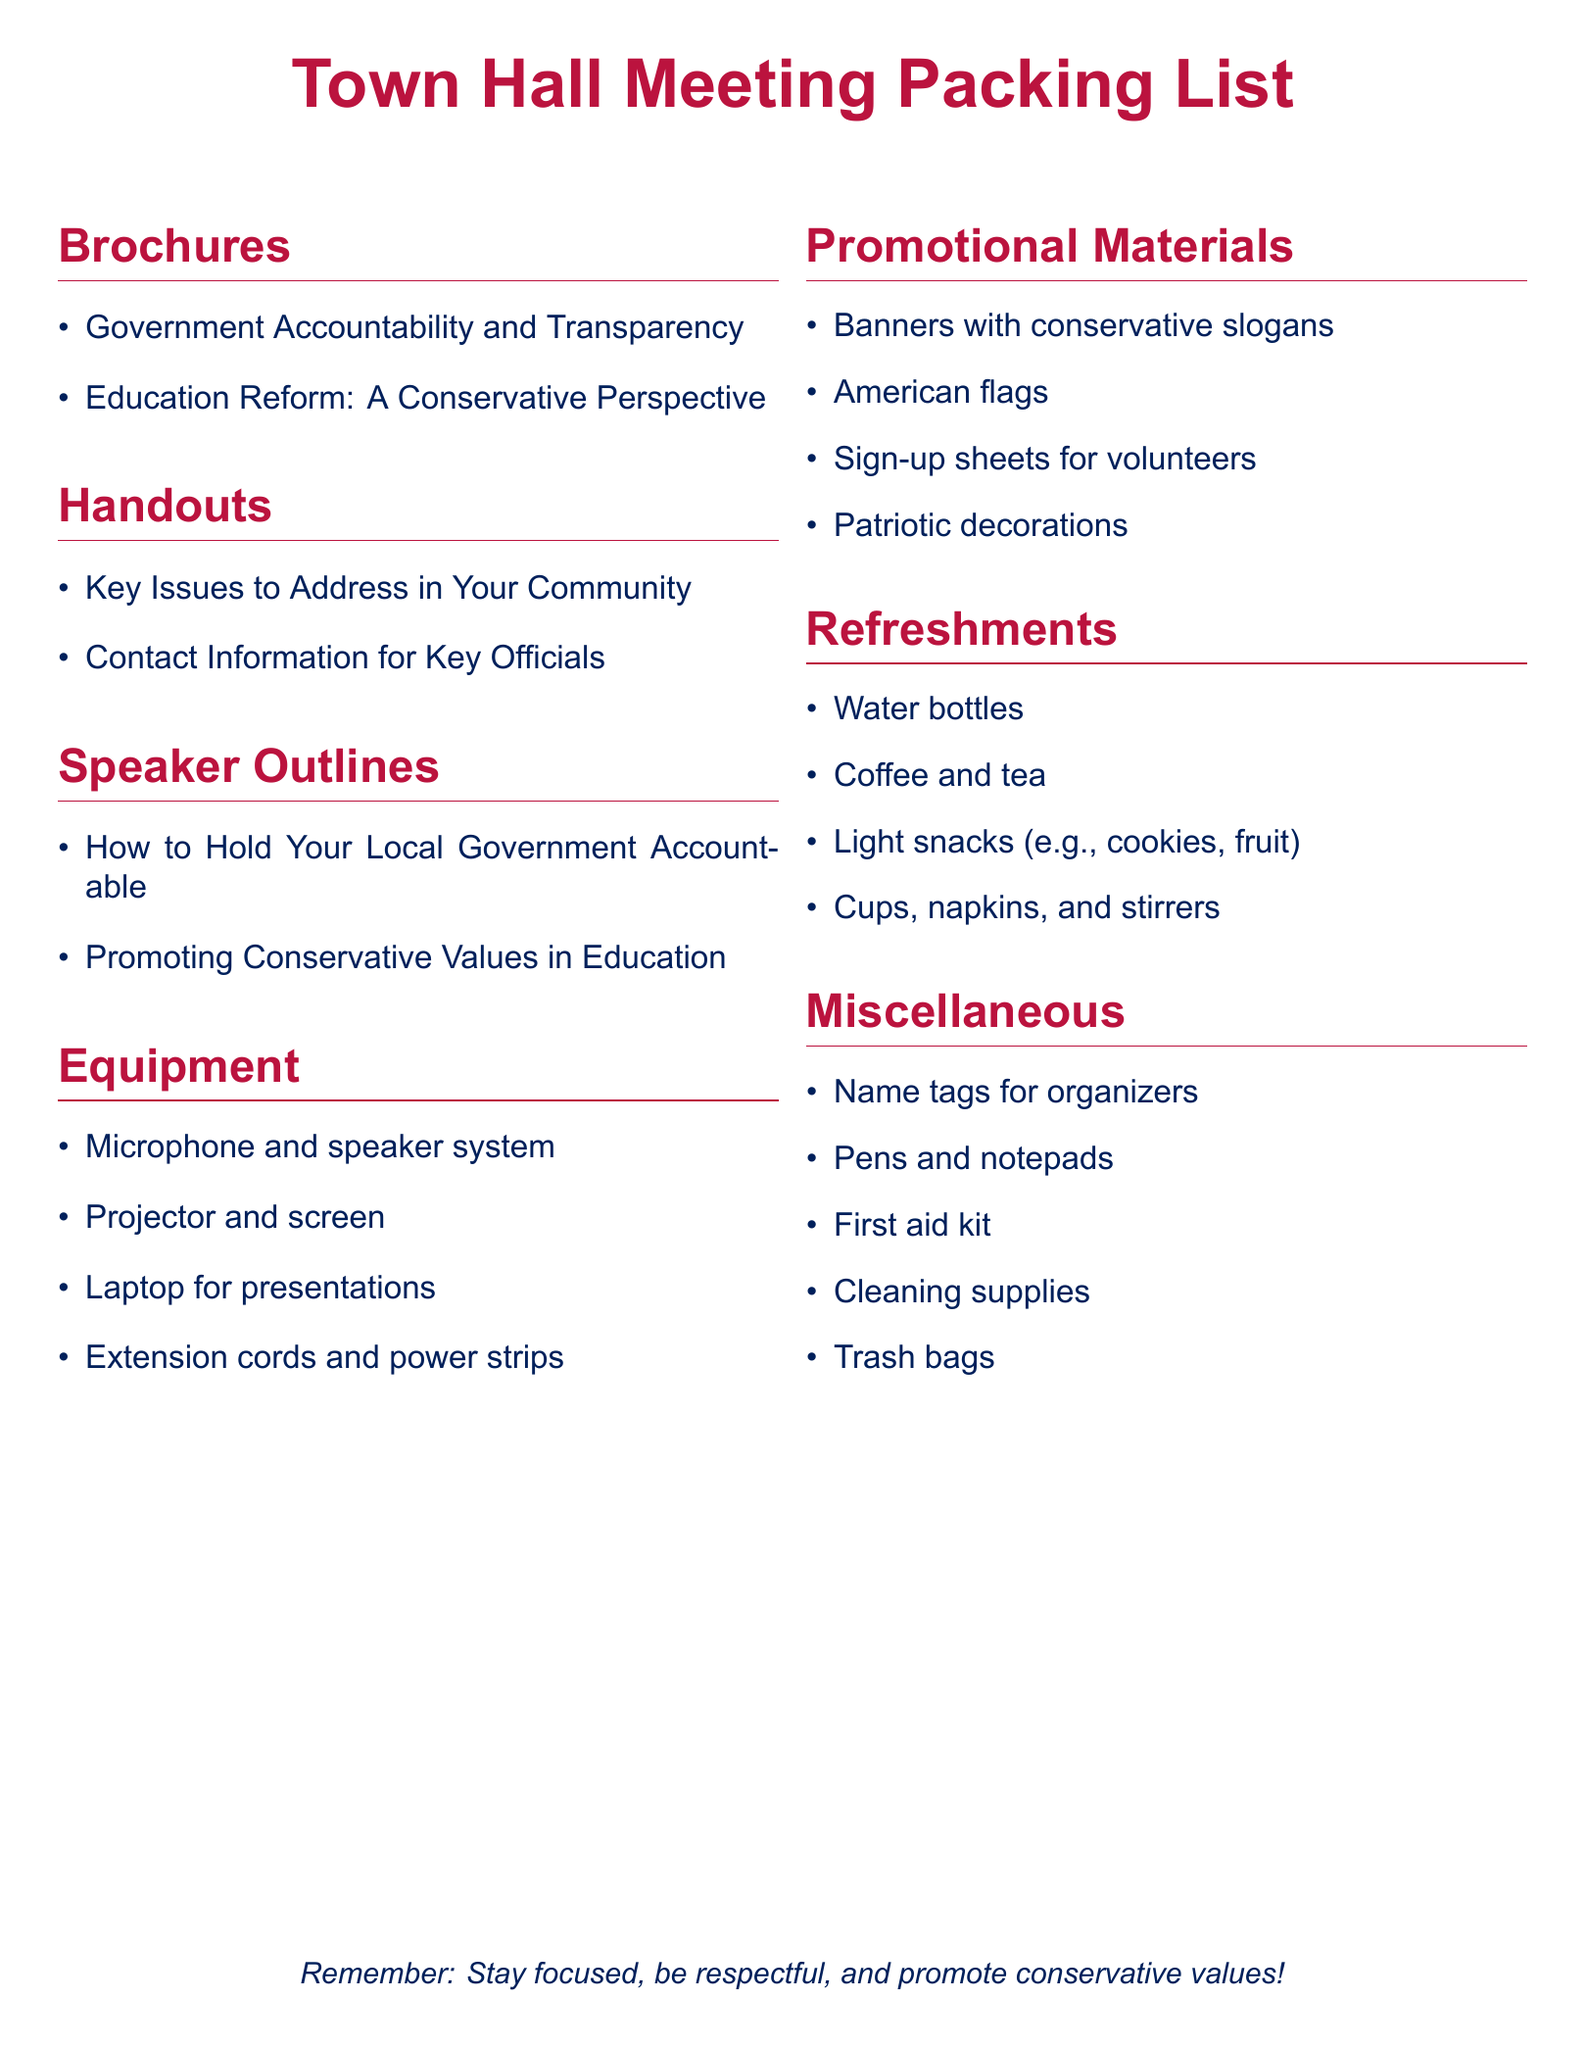What are two types of brochures listed? The document lists brochures related to Government Accountability and Transparency and Education Reform from a Conservative Perspective.
Answer: Government Accountability and Transparency; Education Reform: A Conservative Perspective What items are included under "Handouts"? The handouts section consists of Key Issues to Address in Your Community and Contact Information for Key Officials.
Answer: Key Issues to Address in Your Community; Contact Information for Key Officials How many sections are there in the packing list? The document contains six sections: Brochures, Handouts, Speaker Outlines, Equipment, Promotional Materials, Refreshments, and Miscellaneous, totaling seven sections.
Answer: Seven What is one essential piece of equipment mentioned? The packing list includes items like a microphone and speaker system, which is essential for the meeting.
Answer: Microphone and speaker system What type of refreshments are provided? The refreshments section specifies providing light snacks, which includes cookies and fruit, among other items.
Answer: Light snacks (e.g., cookies, fruit) What is the purpose of the sign-up sheets? The sign-up sheets are intended for gathering information from people willing to volunteer for the event, indicating their involvement and support.
Answer: For volunteers What colors are used in the document for text? The document utilizes patriot blue and patriot red colors for various text elements.
Answer: Patriot blue; patriot red 